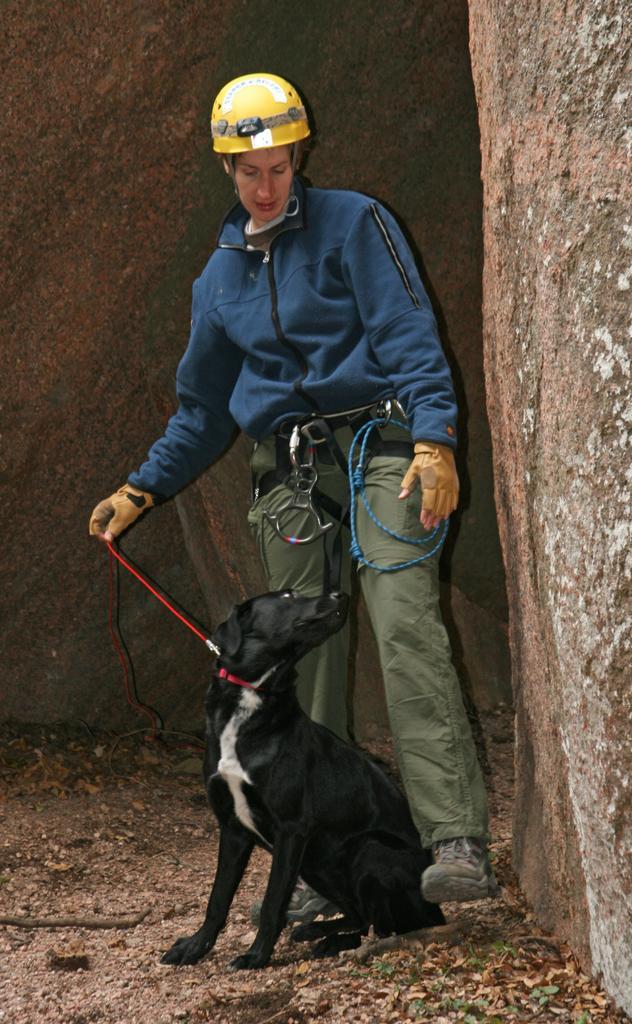Can you describe this image briefly? In this image we can see a person and a dog. In the background we can see rock. 